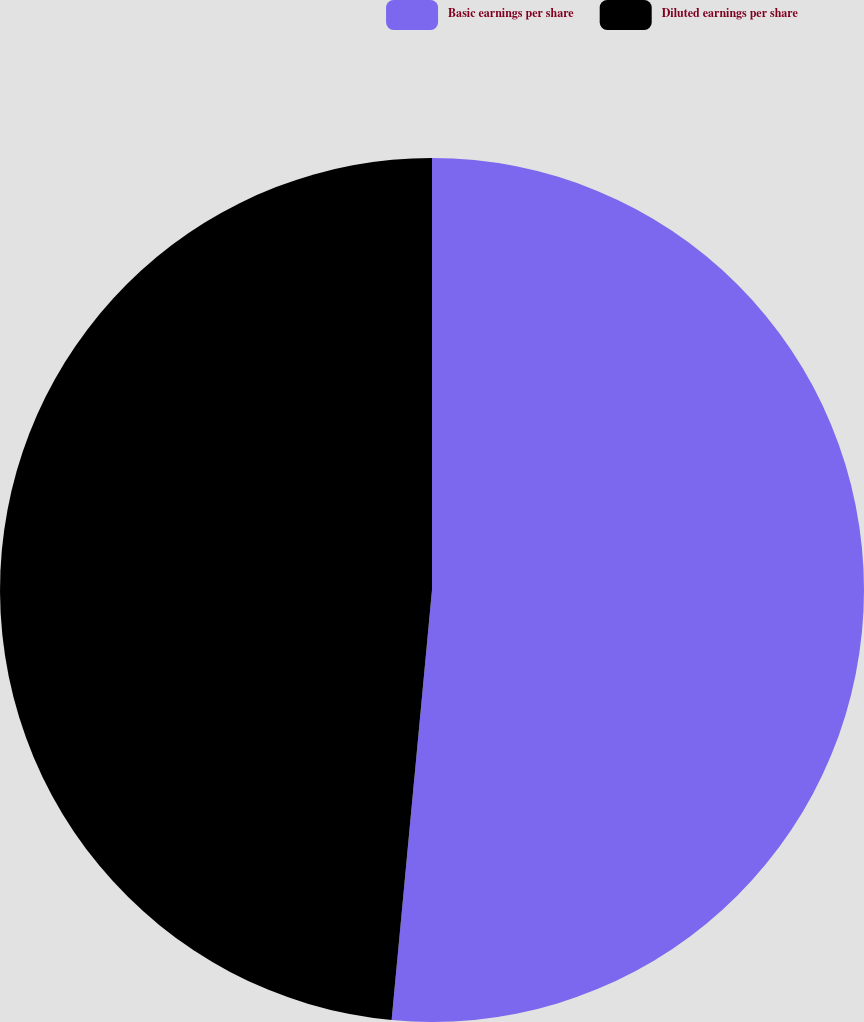Convert chart. <chart><loc_0><loc_0><loc_500><loc_500><pie_chart><fcel>Basic earnings per share<fcel>Diluted earnings per share<nl><fcel>51.49%<fcel>48.51%<nl></chart> 